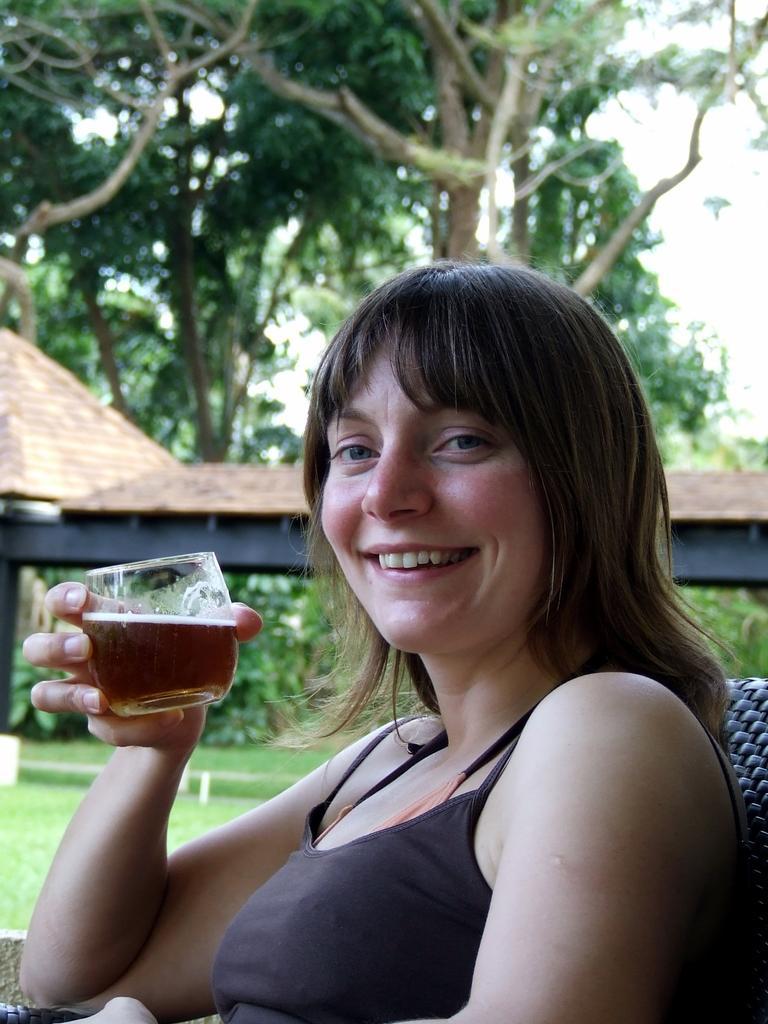Could you give a brief overview of what you see in this image? In this picture we can see woman sitting and holding glass in her hand with drink in it and in background we can see trees, houses, grass. 